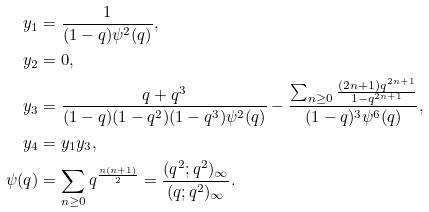Convert formula to latex. <formula><loc_0><loc_0><loc_500><loc_500>y _ { 1 } & = \frac { 1 } { ( 1 - q ) \psi ^ { 2 } ( q ) } , \\ y _ { 2 } & = 0 , \\ y _ { 3 } & = \frac { q + q ^ { 3 } } { ( 1 - q ) ( 1 - q ^ { 2 } ) ( 1 - q ^ { 3 } ) \psi ^ { 2 } ( q ) } - \frac { \sum _ { n \geq 0 } \frac { ( 2 n + 1 ) q ^ { 2 n + 1 } } { 1 - q ^ { 2 n + 1 } } } { ( 1 - q ) ^ { 3 } \psi ^ { 6 } ( q ) } , \\ y _ { 4 } & = y _ { 1 } y _ { 3 } , \\ \psi ( q ) & = \sum _ { n \geq 0 } q ^ { \frac { n ( n + 1 ) } { 2 } } = \frac { ( q ^ { 2 } ; q ^ { 2 } ) _ { \infty } } { ( q ; q ^ { 2 } ) _ { \infty } } . \\</formula> 